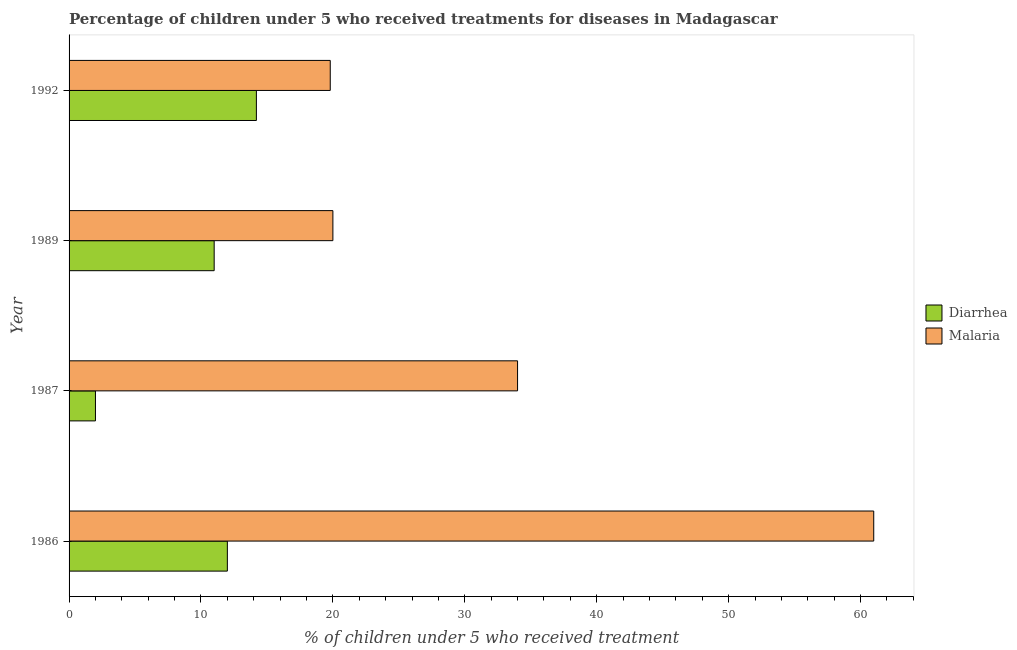How many groups of bars are there?
Your response must be concise. 4. What is the percentage of children who received treatment for malaria in 1992?
Provide a short and direct response. 19.8. Across all years, what is the minimum percentage of children who received treatment for diarrhoea?
Provide a short and direct response. 2. In which year was the percentage of children who received treatment for malaria minimum?
Offer a terse response. 1992. What is the total percentage of children who received treatment for diarrhoea in the graph?
Your answer should be compact. 39.2. What is the difference between the percentage of children who received treatment for diarrhoea in 1987 and that in 1992?
Make the answer very short. -12.2. What is the difference between the percentage of children who received treatment for malaria in 1987 and the percentage of children who received treatment for diarrhoea in 1986?
Keep it short and to the point. 22. What is the average percentage of children who received treatment for diarrhoea per year?
Provide a succinct answer. 9.8. In the year 1989, what is the difference between the percentage of children who received treatment for diarrhoea and percentage of children who received treatment for malaria?
Provide a succinct answer. -9. What is the ratio of the percentage of children who received treatment for diarrhoea in 1986 to that in 1989?
Ensure brevity in your answer.  1.09. What is the difference between the highest and the second highest percentage of children who received treatment for diarrhoea?
Your response must be concise. 2.2. What is the difference between the highest and the lowest percentage of children who received treatment for diarrhoea?
Provide a succinct answer. 12.2. In how many years, is the percentage of children who received treatment for malaria greater than the average percentage of children who received treatment for malaria taken over all years?
Keep it short and to the point. 2. Is the sum of the percentage of children who received treatment for malaria in 1986 and 1992 greater than the maximum percentage of children who received treatment for diarrhoea across all years?
Your answer should be very brief. Yes. What does the 1st bar from the top in 1986 represents?
Make the answer very short. Malaria. What does the 1st bar from the bottom in 1987 represents?
Keep it short and to the point. Diarrhea. How many bars are there?
Your response must be concise. 8. Are all the bars in the graph horizontal?
Your answer should be compact. Yes. How many years are there in the graph?
Offer a terse response. 4. What is the difference between two consecutive major ticks on the X-axis?
Make the answer very short. 10. Does the graph contain grids?
Offer a very short reply. No. How many legend labels are there?
Ensure brevity in your answer.  2. What is the title of the graph?
Your answer should be compact. Percentage of children under 5 who received treatments for diseases in Madagascar. What is the label or title of the X-axis?
Keep it short and to the point. % of children under 5 who received treatment. What is the % of children under 5 who received treatment of Malaria in 1986?
Your response must be concise. 61. What is the % of children under 5 who received treatment in Diarrhea in 1987?
Your answer should be very brief. 2. What is the % of children under 5 who received treatment in Malaria in 1989?
Ensure brevity in your answer.  20. What is the % of children under 5 who received treatment of Diarrhea in 1992?
Your response must be concise. 14.2. What is the % of children under 5 who received treatment in Malaria in 1992?
Provide a succinct answer. 19.8. Across all years, what is the maximum % of children under 5 who received treatment of Malaria?
Offer a very short reply. 61. Across all years, what is the minimum % of children under 5 who received treatment of Malaria?
Ensure brevity in your answer.  19.8. What is the total % of children under 5 who received treatment in Diarrhea in the graph?
Give a very brief answer. 39.2. What is the total % of children under 5 who received treatment of Malaria in the graph?
Ensure brevity in your answer.  134.8. What is the difference between the % of children under 5 who received treatment of Diarrhea in 1986 and that in 1987?
Your answer should be compact. 10. What is the difference between the % of children under 5 who received treatment in Diarrhea in 1986 and that in 1989?
Your answer should be compact. 1. What is the difference between the % of children under 5 who received treatment of Diarrhea in 1986 and that in 1992?
Give a very brief answer. -2.2. What is the difference between the % of children under 5 who received treatment of Malaria in 1986 and that in 1992?
Give a very brief answer. 41.2. What is the difference between the % of children under 5 who received treatment of Diarrhea in 1987 and that in 1992?
Provide a short and direct response. -12.2. What is the difference between the % of children under 5 who received treatment in Malaria in 1987 and that in 1992?
Keep it short and to the point. 14.2. What is the difference between the % of children under 5 who received treatment in Diarrhea in 1989 and that in 1992?
Provide a short and direct response. -3.2. What is the difference between the % of children under 5 who received treatment of Malaria in 1989 and that in 1992?
Your response must be concise. 0.2. What is the difference between the % of children under 5 who received treatment in Diarrhea in 1987 and the % of children under 5 who received treatment in Malaria in 1992?
Offer a very short reply. -17.8. What is the average % of children under 5 who received treatment of Diarrhea per year?
Keep it short and to the point. 9.8. What is the average % of children under 5 who received treatment of Malaria per year?
Provide a short and direct response. 33.7. In the year 1986, what is the difference between the % of children under 5 who received treatment in Diarrhea and % of children under 5 who received treatment in Malaria?
Provide a succinct answer. -49. In the year 1987, what is the difference between the % of children under 5 who received treatment of Diarrhea and % of children under 5 who received treatment of Malaria?
Offer a very short reply. -32. In the year 1989, what is the difference between the % of children under 5 who received treatment in Diarrhea and % of children under 5 who received treatment in Malaria?
Your answer should be compact. -9. In the year 1992, what is the difference between the % of children under 5 who received treatment of Diarrhea and % of children under 5 who received treatment of Malaria?
Give a very brief answer. -5.6. What is the ratio of the % of children under 5 who received treatment in Malaria in 1986 to that in 1987?
Keep it short and to the point. 1.79. What is the ratio of the % of children under 5 who received treatment in Malaria in 1986 to that in 1989?
Your answer should be compact. 3.05. What is the ratio of the % of children under 5 who received treatment in Diarrhea in 1986 to that in 1992?
Give a very brief answer. 0.85. What is the ratio of the % of children under 5 who received treatment of Malaria in 1986 to that in 1992?
Your answer should be compact. 3.08. What is the ratio of the % of children under 5 who received treatment in Diarrhea in 1987 to that in 1989?
Your answer should be compact. 0.18. What is the ratio of the % of children under 5 who received treatment of Diarrhea in 1987 to that in 1992?
Offer a terse response. 0.14. What is the ratio of the % of children under 5 who received treatment of Malaria in 1987 to that in 1992?
Provide a succinct answer. 1.72. What is the ratio of the % of children under 5 who received treatment in Diarrhea in 1989 to that in 1992?
Provide a short and direct response. 0.77. What is the difference between the highest and the second highest % of children under 5 who received treatment of Diarrhea?
Provide a short and direct response. 2.2. What is the difference between the highest and the second highest % of children under 5 who received treatment in Malaria?
Give a very brief answer. 27. What is the difference between the highest and the lowest % of children under 5 who received treatment in Diarrhea?
Provide a succinct answer. 12.2. What is the difference between the highest and the lowest % of children under 5 who received treatment in Malaria?
Offer a terse response. 41.2. 